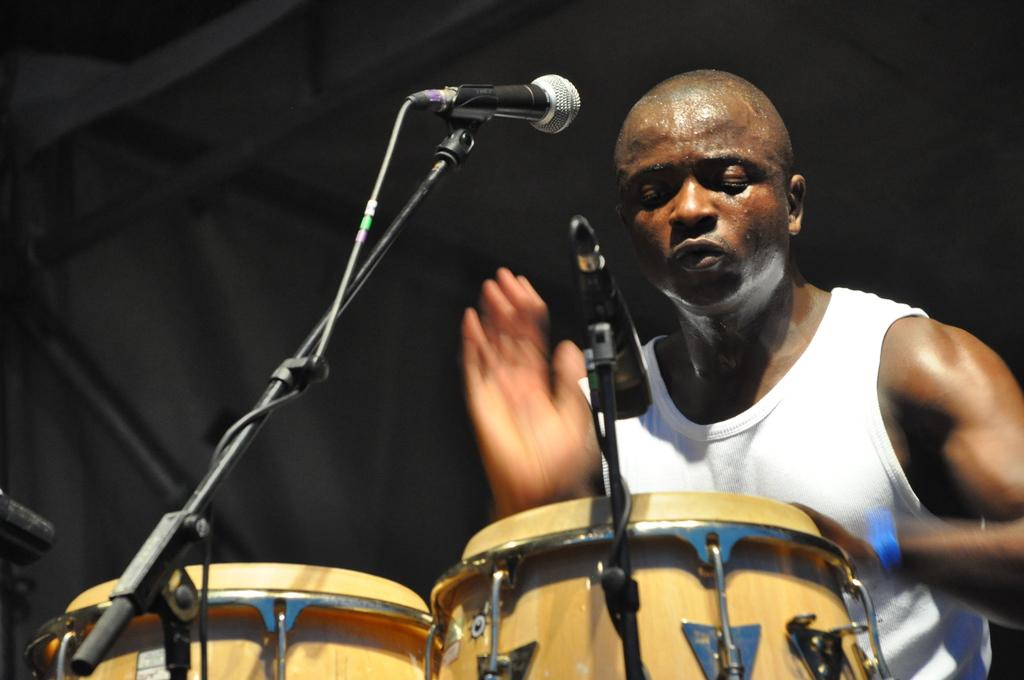What is the main activity taking place in the foreground of the image? There is a person playing drums in the foreground. What equipment is visible near the drummer? There are microphones, stands, cables, and drums in the foreground. How are the microphones positioned in the image? The microphones are in the foreground, likely to capture the sound of the drums. Can you describe the background of the image? The background of the image is blurred, which may indicate a shallow depth of field or a focus on the foreground elements. How many legs does the print on the wall have in the image? There is no print on the wall in the image, so it is not possible to determine the number of legs it might have. 